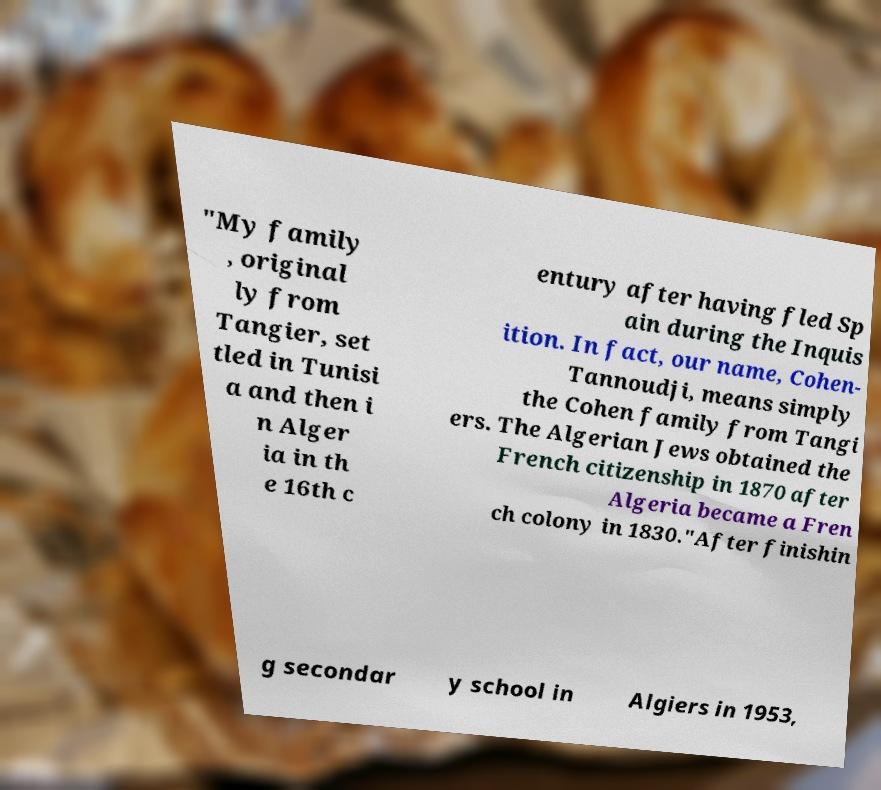Please read and relay the text visible in this image. What does it say? "My family , original ly from Tangier, set tled in Tunisi a and then i n Alger ia in th e 16th c entury after having fled Sp ain during the Inquis ition. In fact, our name, Cohen- Tannoudji, means simply the Cohen family from Tangi ers. The Algerian Jews obtained the French citizenship in 1870 after Algeria became a Fren ch colony in 1830."After finishin g secondar y school in Algiers in 1953, 